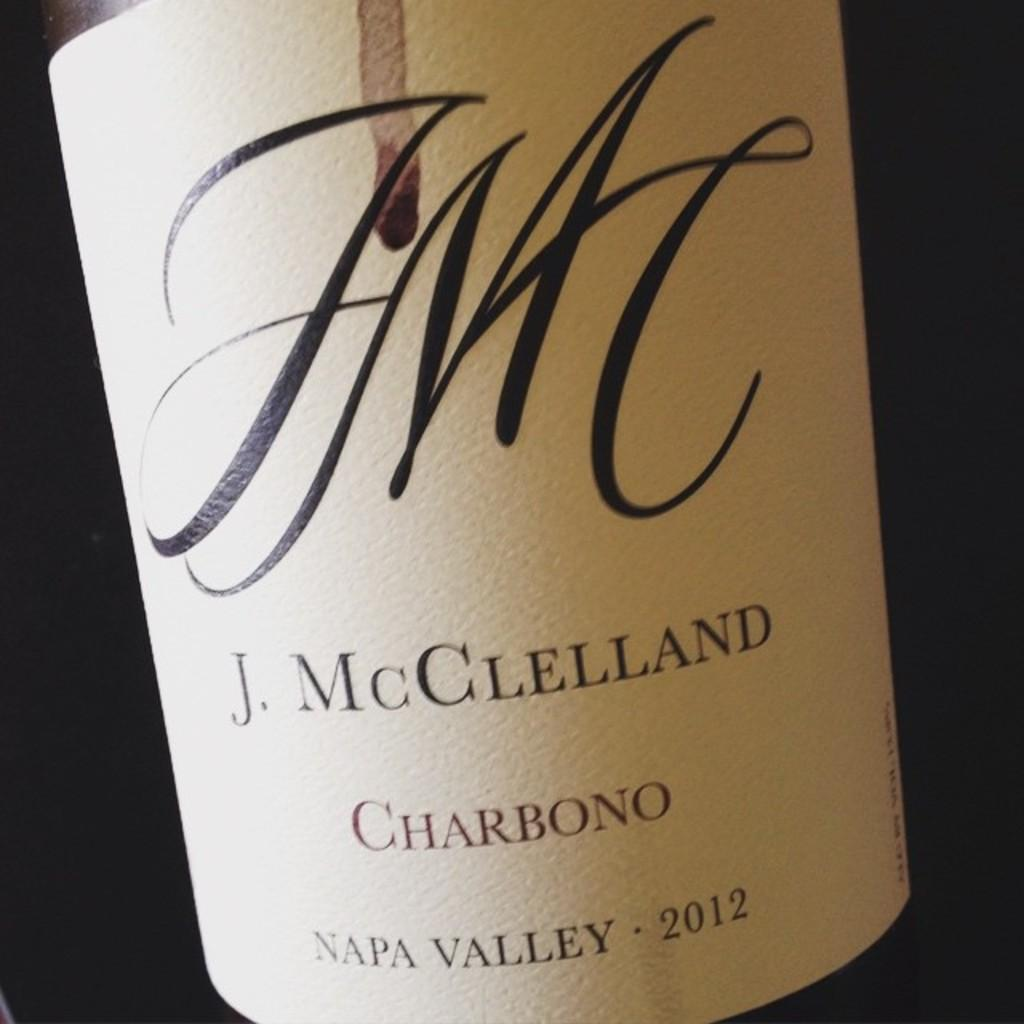<image>
Summarize the visual content of the image. A 2012 bottle of J. McClelland wine from Napa Valley. 